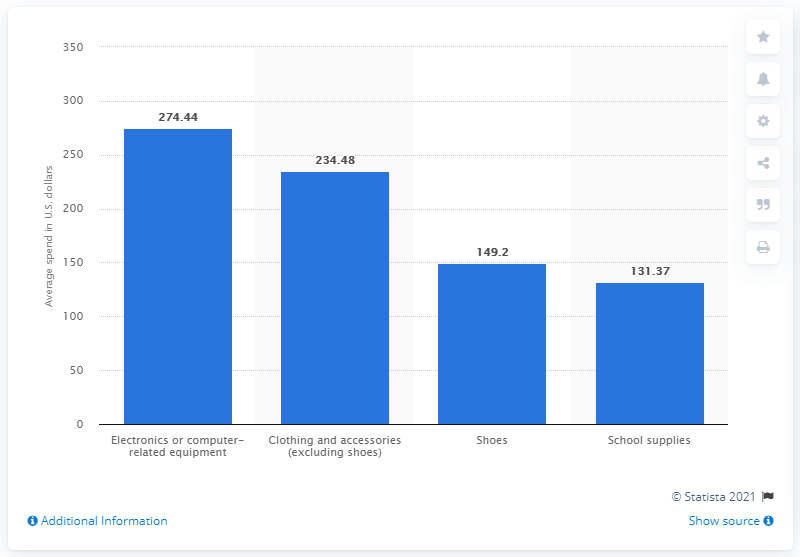Draw attention to some important aspects in this diagram. According to a survey conducted in 2020, parents expected to spend an average of 234.48 on their children's back-to-school clothing and accessories. 